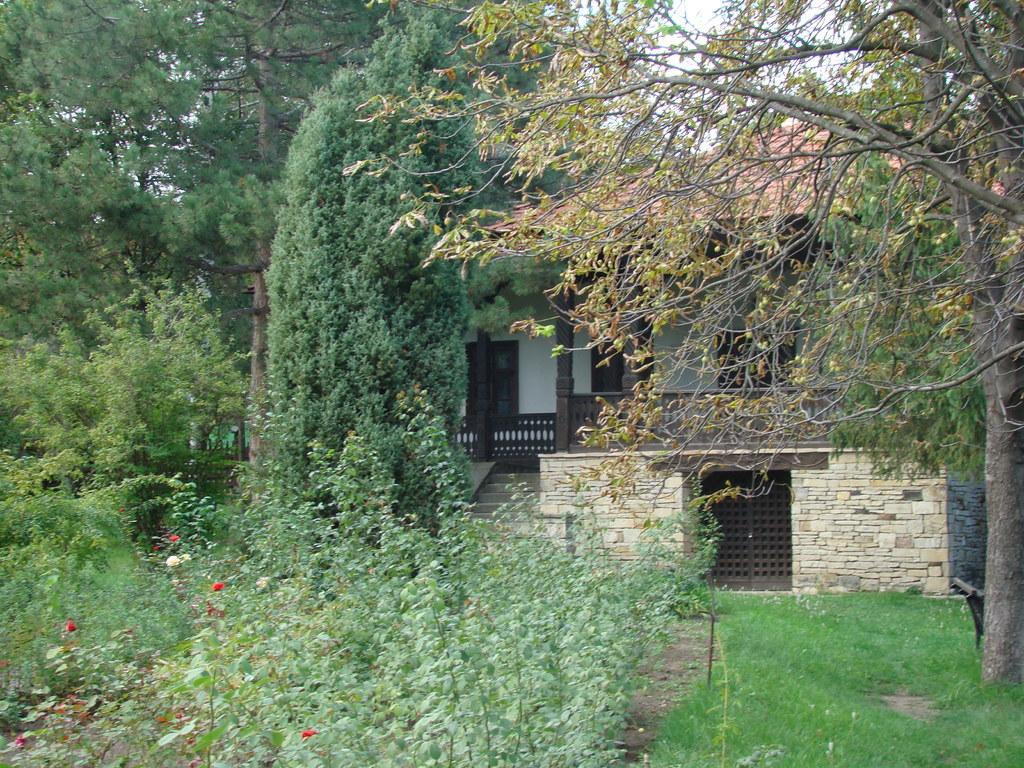What is the main subject in the center of the image? There is a house in the center of the image. What can be seen in the background of the image? There are trees and the sky visible in the background of the image. What type of vegetation is present at the bottom of the image? There are plants and grass at the bottom of the image. How many oranges are hanging from the trees in the image? There are no oranges visible in the image; only trees are present in the background. Is there a bridge connecting the house to the trees in the image? There is no bridge present in the image; only the house, trees, and sky are visible. 